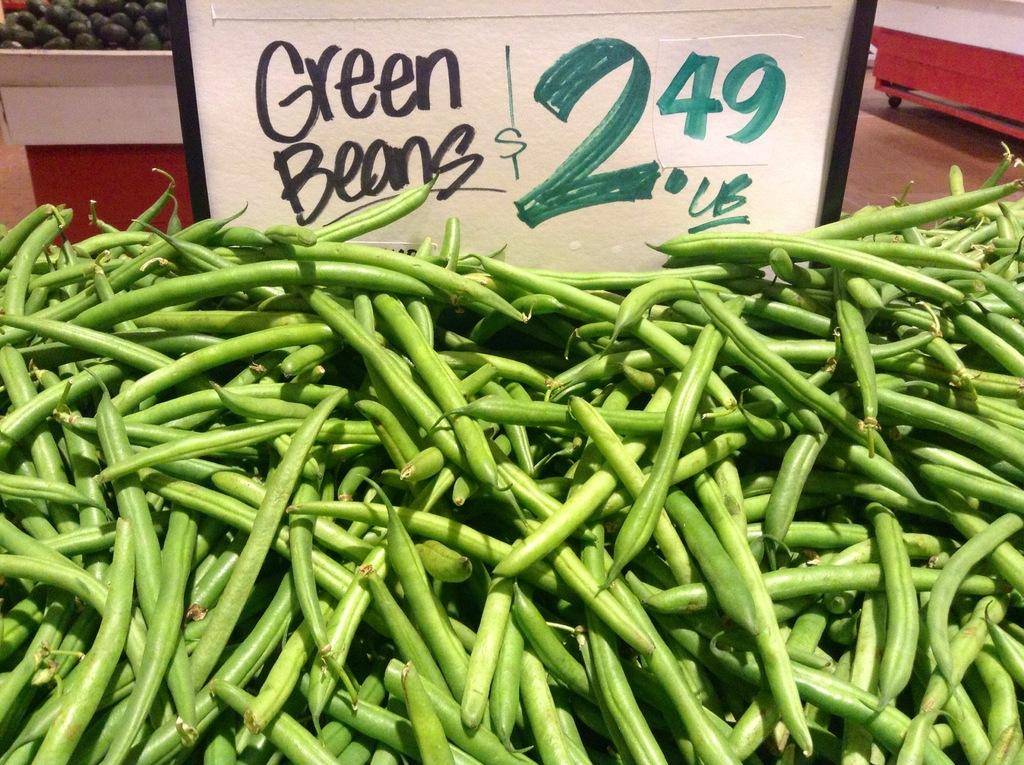What type of food is shown in the image? There are beans in the image. What else can be seen in the image besides the beans? There is text, a price on a board, vegetables, and tables visible in the image. How many historical bridges can be seen in the image? There are no historical bridges present in the image. What part of the body is shown interacting with the beans in the image? There are no body parts interacting with the beans in the image. 